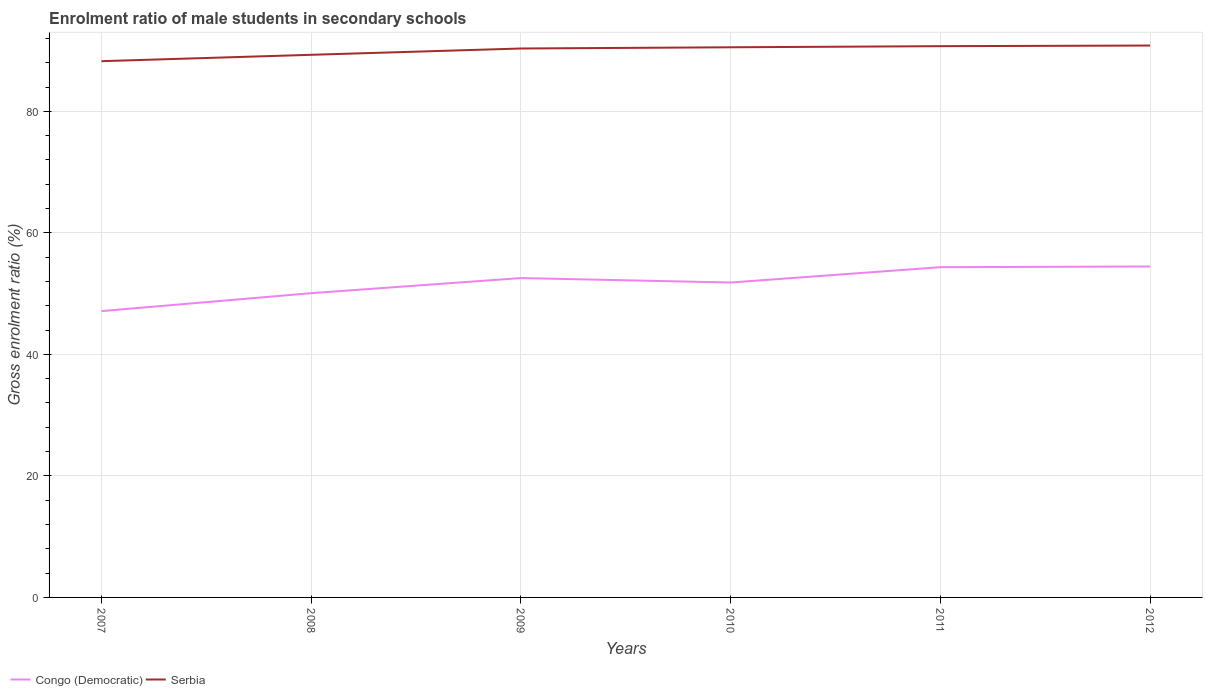How many different coloured lines are there?
Provide a short and direct response. 2. Does the line corresponding to Serbia intersect with the line corresponding to Congo (Democratic)?
Provide a succinct answer. No. Is the number of lines equal to the number of legend labels?
Your response must be concise. Yes. Across all years, what is the maximum enrolment ratio of male students in secondary schools in Congo (Democratic)?
Make the answer very short. 47.13. In which year was the enrolment ratio of male students in secondary schools in Congo (Democratic) maximum?
Make the answer very short. 2007. What is the total enrolment ratio of male students in secondary schools in Serbia in the graph?
Your answer should be compact. -2.47. What is the difference between the highest and the second highest enrolment ratio of male students in secondary schools in Congo (Democratic)?
Ensure brevity in your answer.  7.34. What is the difference between the highest and the lowest enrolment ratio of male students in secondary schools in Serbia?
Your response must be concise. 4. How many years are there in the graph?
Provide a succinct answer. 6. Where does the legend appear in the graph?
Provide a succinct answer. Bottom left. How many legend labels are there?
Provide a short and direct response. 2. What is the title of the graph?
Provide a succinct answer. Enrolment ratio of male students in secondary schools. What is the label or title of the Y-axis?
Offer a terse response. Gross enrolment ratio (%). What is the Gross enrolment ratio (%) in Congo (Democratic) in 2007?
Provide a short and direct response. 47.13. What is the Gross enrolment ratio (%) of Serbia in 2007?
Keep it short and to the point. 88.26. What is the Gross enrolment ratio (%) in Congo (Democratic) in 2008?
Give a very brief answer. 50.08. What is the Gross enrolment ratio (%) in Serbia in 2008?
Provide a succinct answer. 89.31. What is the Gross enrolment ratio (%) of Congo (Democratic) in 2009?
Ensure brevity in your answer.  52.56. What is the Gross enrolment ratio (%) in Serbia in 2009?
Provide a succinct answer. 90.34. What is the Gross enrolment ratio (%) of Congo (Democratic) in 2010?
Provide a succinct answer. 51.83. What is the Gross enrolment ratio (%) of Serbia in 2010?
Provide a short and direct response. 90.54. What is the Gross enrolment ratio (%) in Congo (Democratic) in 2011?
Offer a very short reply. 54.35. What is the Gross enrolment ratio (%) in Serbia in 2011?
Your answer should be compact. 90.73. What is the Gross enrolment ratio (%) of Congo (Democratic) in 2012?
Ensure brevity in your answer.  54.47. What is the Gross enrolment ratio (%) of Serbia in 2012?
Offer a terse response. 90.83. Across all years, what is the maximum Gross enrolment ratio (%) of Congo (Democratic)?
Offer a very short reply. 54.47. Across all years, what is the maximum Gross enrolment ratio (%) of Serbia?
Provide a short and direct response. 90.83. Across all years, what is the minimum Gross enrolment ratio (%) of Congo (Democratic)?
Your answer should be very brief. 47.13. Across all years, what is the minimum Gross enrolment ratio (%) in Serbia?
Ensure brevity in your answer.  88.26. What is the total Gross enrolment ratio (%) of Congo (Democratic) in the graph?
Ensure brevity in your answer.  310.41. What is the total Gross enrolment ratio (%) of Serbia in the graph?
Provide a succinct answer. 540.01. What is the difference between the Gross enrolment ratio (%) of Congo (Democratic) in 2007 and that in 2008?
Offer a terse response. -2.95. What is the difference between the Gross enrolment ratio (%) of Serbia in 2007 and that in 2008?
Your response must be concise. -1.05. What is the difference between the Gross enrolment ratio (%) of Congo (Democratic) in 2007 and that in 2009?
Provide a succinct answer. -5.44. What is the difference between the Gross enrolment ratio (%) of Serbia in 2007 and that in 2009?
Keep it short and to the point. -2.09. What is the difference between the Gross enrolment ratio (%) in Congo (Democratic) in 2007 and that in 2010?
Your answer should be very brief. -4.7. What is the difference between the Gross enrolment ratio (%) of Serbia in 2007 and that in 2010?
Your answer should be compact. -2.29. What is the difference between the Gross enrolment ratio (%) of Congo (Democratic) in 2007 and that in 2011?
Offer a terse response. -7.23. What is the difference between the Gross enrolment ratio (%) of Serbia in 2007 and that in 2011?
Make the answer very short. -2.47. What is the difference between the Gross enrolment ratio (%) of Congo (Democratic) in 2007 and that in 2012?
Your answer should be compact. -7.34. What is the difference between the Gross enrolment ratio (%) in Serbia in 2007 and that in 2012?
Your answer should be very brief. -2.58. What is the difference between the Gross enrolment ratio (%) of Congo (Democratic) in 2008 and that in 2009?
Provide a succinct answer. -2.49. What is the difference between the Gross enrolment ratio (%) of Serbia in 2008 and that in 2009?
Ensure brevity in your answer.  -1.04. What is the difference between the Gross enrolment ratio (%) of Congo (Democratic) in 2008 and that in 2010?
Provide a short and direct response. -1.75. What is the difference between the Gross enrolment ratio (%) in Serbia in 2008 and that in 2010?
Your answer should be very brief. -1.24. What is the difference between the Gross enrolment ratio (%) in Congo (Democratic) in 2008 and that in 2011?
Ensure brevity in your answer.  -4.28. What is the difference between the Gross enrolment ratio (%) in Serbia in 2008 and that in 2011?
Your answer should be compact. -1.42. What is the difference between the Gross enrolment ratio (%) in Congo (Democratic) in 2008 and that in 2012?
Keep it short and to the point. -4.39. What is the difference between the Gross enrolment ratio (%) of Serbia in 2008 and that in 2012?
Your response must be concise. -1.53. What is the difference between the Gross enrolment ratio (%) in Congo (Democratic) in 2009 and that in 2010?
Make the answer very short. 0.73. What is the difference between the Gross enrolment ratio (%) in Serbia in 2009 and that in 2010?
Offer a terse response. -0.2. What is the difference between the Gross enrolment ratio (%) of Congo (Democratic) in 2009 and that in 2011?
Offer a terse response. -1.79. What is the difference between the Gross enrolment ratio (%) in Serbia in 2009 and that in 2011?
Give a very brief answer. -0.38. What is the difference between the Gross enrolment ratio (%) in Congo (Democratic) in 2009 and that in 2012?
Provide a succinct answer. -1.9. What is the difference between the Gross enrolment ratio (%) of Serbia in 2009 and that in 2012?
Ensure brevity in your answer.  -0.49. What is the difference between the Gross enrolment ratio (%) in Congo (Democratic) in 2010 and that in 2011?
Give a very brief answer. -2.52. What is the difference between the Gross enrolment ratio (%) in Serbia in 2010 and that in 2011?
Ensure brevity in your answer.  -0.18. What is the difference between the Gross enrolment ratio (%) in Congo (Democratic) in 2010 and that in 2012?
Provide a short and direct response. -2.64. What is the difference between the Gross enrolment ratio (%) of Serbia in 2010 and that in 2012?
Keep it short and to the point. -0.29. What is the difference between the Gross enrolment ratio (%) of Congo (Democratic) in 2011 and that in 2012?
Your answer should be very brief. -0.11. What is the difference between the Gross enrolment ratio (%) of Serbia in 2011 and that in 2012?
Keep it short and to the point. -0.11. What is the difference between the Gross enrolment ratio (%) of Congo (Democratic) in 2007 and the Gross enrolment ratio (%) of Serbia in 2008?
Offer a terse response. -42.18. What is the difference between the Gross enrolment ratio (%) of Congo (Democratic) in 2007 and the Gross enrolment ratio (%) of Serbia in 2009?
Offer a terse response. -43.22. What is the difference between the Gross enrolment ratio (%) of Congo (Democratic) in 2007 and the Gross enrolment ratio (%) of Serbia in 2010?
Give a very brief answer. -43.42. What is the difference between the Gross enrolment ratio (%) of Congo (Democratic) in 2007 and the Gross enrolment ratio (%) of Serbia in 2011?
Make the answer very short. -43.6. What is the difference between the Gross enrolment ratio (%) in Congo (Democratic) in 2007 and the Gross enrolment ratio (%) in Serbia in 2012?
Offer a terse response. -43.71. What is the difference between the Gross enrolment ratio (%) in Congo (Democratic) in 2008 and the Gross enrolment ratio (%) in Serbia in 2009?
Provide a short and direct response. -40.27. What is the difference between the Gross enrolment ratio (%) in Congo (Democratic) in 2008 and the Gross enrolment ratio (%) in Serbia in 2010?
Your answer should be compact. -40.47. What is the difference between the Gross enrolment ratio (%) in Congo (Democratic) in 2008 and the Gross enrolment ratio (%) in Serbia in 2011?
Ensure brevity in your answer.  -40.65. What is the difference between the Gross enrolment ratio (%) in Congo (Democratic) in 2008 and the Gross enrolment ratio (%) in Serbia in 2012?
Provide a succinct answer. -40.76. What is the difference between the Gross enrolment ratio (%) in Congo (Democratic) in 2009 and the Gross enrolment ratio (%) in Serbia in 2010?
Keep it short and to the point. -37.98. What is the difference between the Gross enrolment ratio (%) in Congo (Democratic) in 2009 and the Gross enrolment ratio (%) in Serbia in 2011?
Your answer should be very brief. -38.16. What is the difference between the Gross enrolment ratio (%) in Congo (Democratic) in 2009 and the Gross enrolment ratio (%) in Serbia in 2012?
Offer a terse response. -38.27. What is the difference between the Gross enrolment ratio (%) of Congo (Democratic) in 2010 and the Gross enrolment ratio (%) of Serbia in 2011?
Provide a short and direct response. -38.9. What is the difference between the Gross enrolment ratio (%) of Congo (Democratic) in 2010 and the Gross enrolment ratio (%) of Serbia in 2012?
Provide a succinct answer. -39. What is the difference between the Gross enrolment ratio (%) in Congo (Democratic) in 2011 and the Gross enrolment ratio (%) in Serbia in 2012?
Offer a very short reply. -36.48. What is the average Gross enrolment ratio (%) in Congo (Democratic) per year?
Ensure brevity in your answer.  51.74. What is the average Gross enrolment ratio (%) of Serbia per year?
Keep it short and to the point. 90. In the year 2007, what is the difference between the Gross enrolment ratio (%) in Congo (Democratic) and Gross enrolment ratio (%) in Serbia?
Your answer should be very brief. -41.13. In the year 2008, what is the difference between the Gross enrolment ratio (%) in Congo (Democratic) and Gross enrolment ratio (%) in Serbia?
Keep it short and to the point. -39.23. In the year 2009, what is the difference between the Gross enrolment ratio (%) of Congo (Democratic) and Gross enrolment ratio (%) of Serbia?
Keep it short and to the point. -37.78. In the year 2010, what is the difference between the Gross enrolment ratio (%) in Congo (Democratic) and Gross enrolment ratio (%) in Serbia?
Give a very brief answer. -38.72. In the year 2011, what is the difference between the Gross enrolment ratio (%) of Congo (Democratic) and Gross enrolment ratio (%) of Serbia?
Make the answer very short. -36.38. In the year 2012, what is the difference between the Gross enrolment ratio (%) in Congo (Democratic) and Gross enrolment ratio (%) in Serbia?
Give a very brief answer. -36.37. What is the ratio of the Gross enrolment ratio (%) in Congo (Democratic) in 2007 to that in 2008?
Give a very brief answer. 0.94. What is the ratio of the Gross enrolment ratio (%) of Serbia in 2007 to that in 2008?
Give a very brief answer. 0.99. What is the ratio of the Gross enrolment ratio (%) in Congo (Democratic) in 2007 to that in 2009?
Your response must be concise. 0.9. What is the ratio of the Gross enrolment ratio (%) in Serbia in 2007 to that in 2009?
Give a very brief answer. 0.98. What is the ratio of the Gross enrolment ratio (%) of Congo (Democratic) in 2007 to that in 2010?
Provide a succinct answer. 0.91. What is the ratio of the Gross enrolment ratio (%) of Serbia in 2007 to that in 2010?
Your response must be concise. 0.97. What is the ratio of the Gross enrolment ratio (%) of Congo (Democratic) in 2007 to that in 2011?
Provide a succinct answer. 0.87. What is the ratio of the Gross enrolment ratio (%) in Serbia in 2007 to that in 2011?
Ensure brevity in your answer.  0.97. What is the ratio of the Gross enrolment ratio (%) in Congo (Democratic) in 2007 to that in 2012?
Give a very brief answer. 0.87. What is the ratio of the Gross enrolment ratio (%) of Serbia in 2007 to that in 2012?
Keep it short and to the point. 0.97. What is the ratio of the Gross enrolment ratio (%) of Congo (Democratic) in 2008 to that in 2009?
Provide a succinct answer. 0.95. What is the ratio of the Gross enrolment ratio (%) in Serbia in 2008 to that in 2009?
Your answer should be compact. 0.99. What is the ratio of the Gross enrolment ratio (%) in Congo (Democratic) in 2008 to that in 2010?
Provide a succinct answer. 0.97. What is the ratio of the Gross enrolment ratio (%) of Serbia in 2008 to that in 2010?
Give a very brief answer. 0.99. What is the ratio of the Gross enrolment ratio (%) in Congo (Democratic) in 2008 to that in 2011?
Offer a terse response. 0.92. What is the ratio of the Gross enrolment ratio (%) in Serbia in 2008 to that in 2011?
Offer a very short reply. 0.98. What is the ratio of the Gross enrolment ratio (%) in Congo (Democratic) in 2008 to that in 2012?
Offer a terse response. 0.92. What is the ratio of the Gross enrolment ratio (%) of Serbia in 2008 to that in 2012?
Provide a short and direct response. 0.98. What is the ratio of the Gross enrolment ratio (%) of Congo (Democratic) in 2009 to that in 2010?
Offer a terse response. 1.01. What is the ratio of the Gross enrolment ratio (%) of Serbia in 2009 to that in 2010?
Your response must be concise. 1. What is the ratio of the Gross enrolment ratio (%) of Congo (Democratic) in 2009 to that in 2011?
Your response must be concise. 0.97. What is the ratio of the Gross enrolment ratio (%) of Congo (Democratic) in 2009 to that in 2012?
Keep it short and to the point. 0.97. What is the ratio of the Gross enrolment ratio (%) of Serbia in 2009 to that in 2012?
Provide a short and direct response. 0.99. What is the ratio of the Gross enrolment ratio (%) of Congo (Democratic) in 2010 to that in 2011?
Provide a short and direct response. 0.95. What is the ratio of the Gross enrolment ratio (%) in Congo (Democratic) in 2010 to that in 2012?
Ensure brevity in your answer.  0.95. What is the difference between the highest and the second highest Gross enrolment ratio (%) in Congo (Democratic)?
Offer a terse response. 0.11. What is the difference between the highest and the second highest Gross enrolment ratio (%) of Serbia?
Your answer should be compact. 0.11. What is the difference between the highest and the lowest Gross enrolment ratio (%) of Congo (Democratic)?
Offer a very short reply. 7.34. What is the difference between the highest and the lowest Gross enrolment ratio (%) of Serbia?
Offer a very short reply. 2.58. 